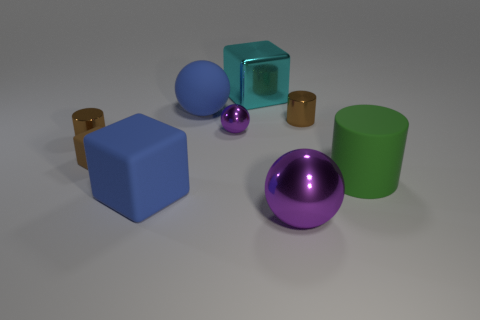There is a metallic cylinder behind the brown cylinder to the left of the big metallic block; what is its size?
Ensure brevity in your answer.  Small. Are there any small purple spheres made of the same material as the big cyan thing?
Provide a short and direct response. Yes. The small brown metal object right of the large ball that is in front of the cylinder on the left side of the cyan metallic thing is what shape?
Keep it short and to the point. Cylinder. Is the color of the large sphere in front of the large blue ball the same as the cube to the right of the large rubber cube?
Provide a short and direct response. No. Are there any tiny brown metal cylinders behind the large cyan metal object?
Give a very brief answer. No. How many tiny rubber things have the same shape as the big purple object?
Keep it short and to the point. 0. What color is the big ball that is in front of the small shiny thing that is to the right of the large block that is behind the blue cube?
Offer a terse response. Purple. Do the big blue thing on the left side of the matte ball and the small cylinder that is behind the tiny purple metal thing have the same material?
Provide a short and direct response. No. How many objects are small things that are right of the tiny brown matte block or tiny rubber blocks?
Give a very brief answer. 3. What number of things are either gray metal things or shiny balls that are in front of the big green thing?
Provide a short and direct response. 1. 